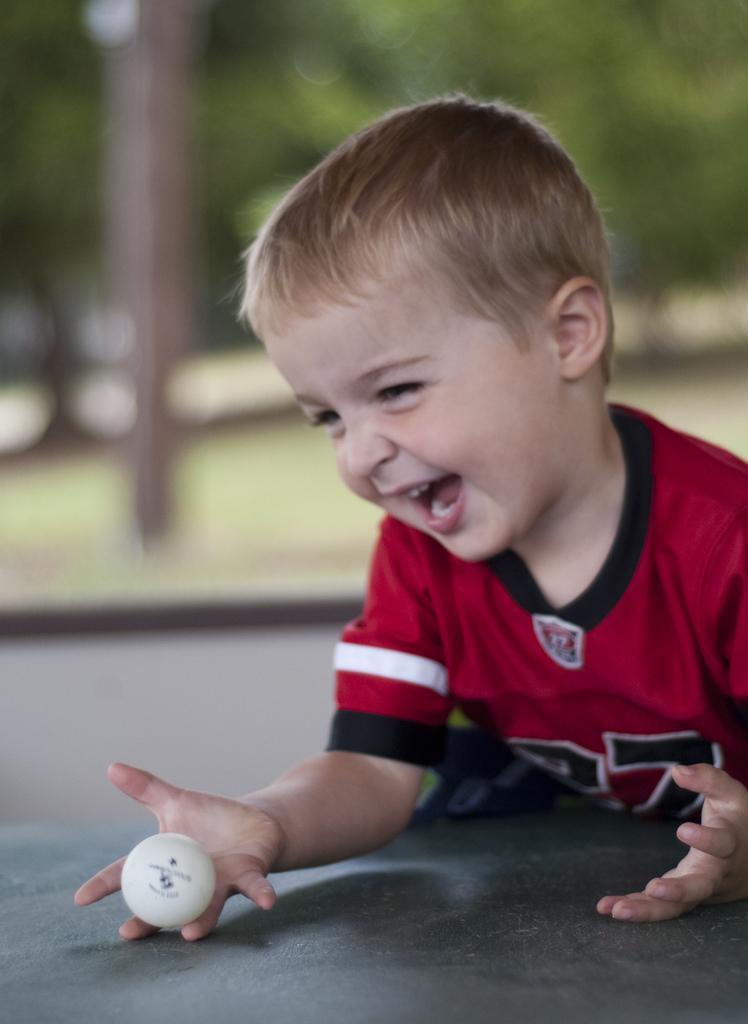How would you summarize this image in a sentence or two? This image consists of a boy holding a ball. At the bottom, there is a floor. In the background, there are trees. And the background is blurred. 